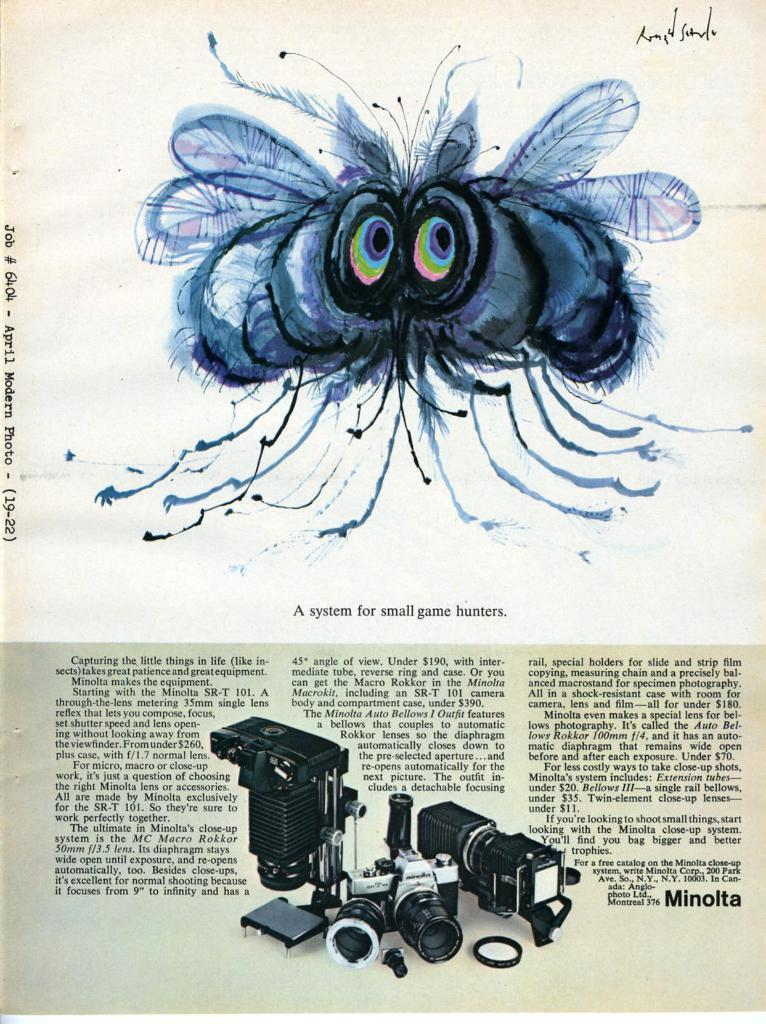What is the main subject of the photo in the image? The main subject of the photo in the image is a newspaper. What other objects can be seen in the photo? The photo contains cameras. Can you read any text in the photo? Yes, there is text visible in the photo. What type of gun is being used to take the photo of the newspaper? There is no gun present in the image; the photo is taken using cameras. How many teeth can be seen in the photo of the newspaper? There are no teeth visible in the photo of the newspaper. 